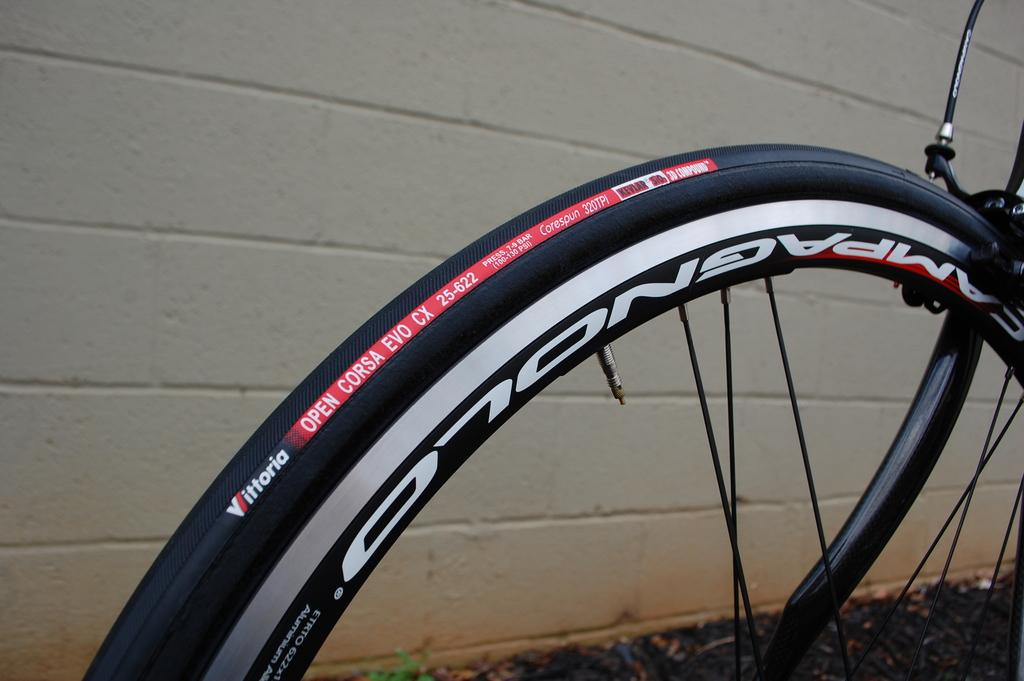What is the main object in the image? There is a bicycle in the image. What can be seen in the background of the image? There is a wall in the background of the image. What type of lamp is hanging from the wire in the image? There is no lamp or wire present in the image; it only features a bicycle and a wall in the background. 